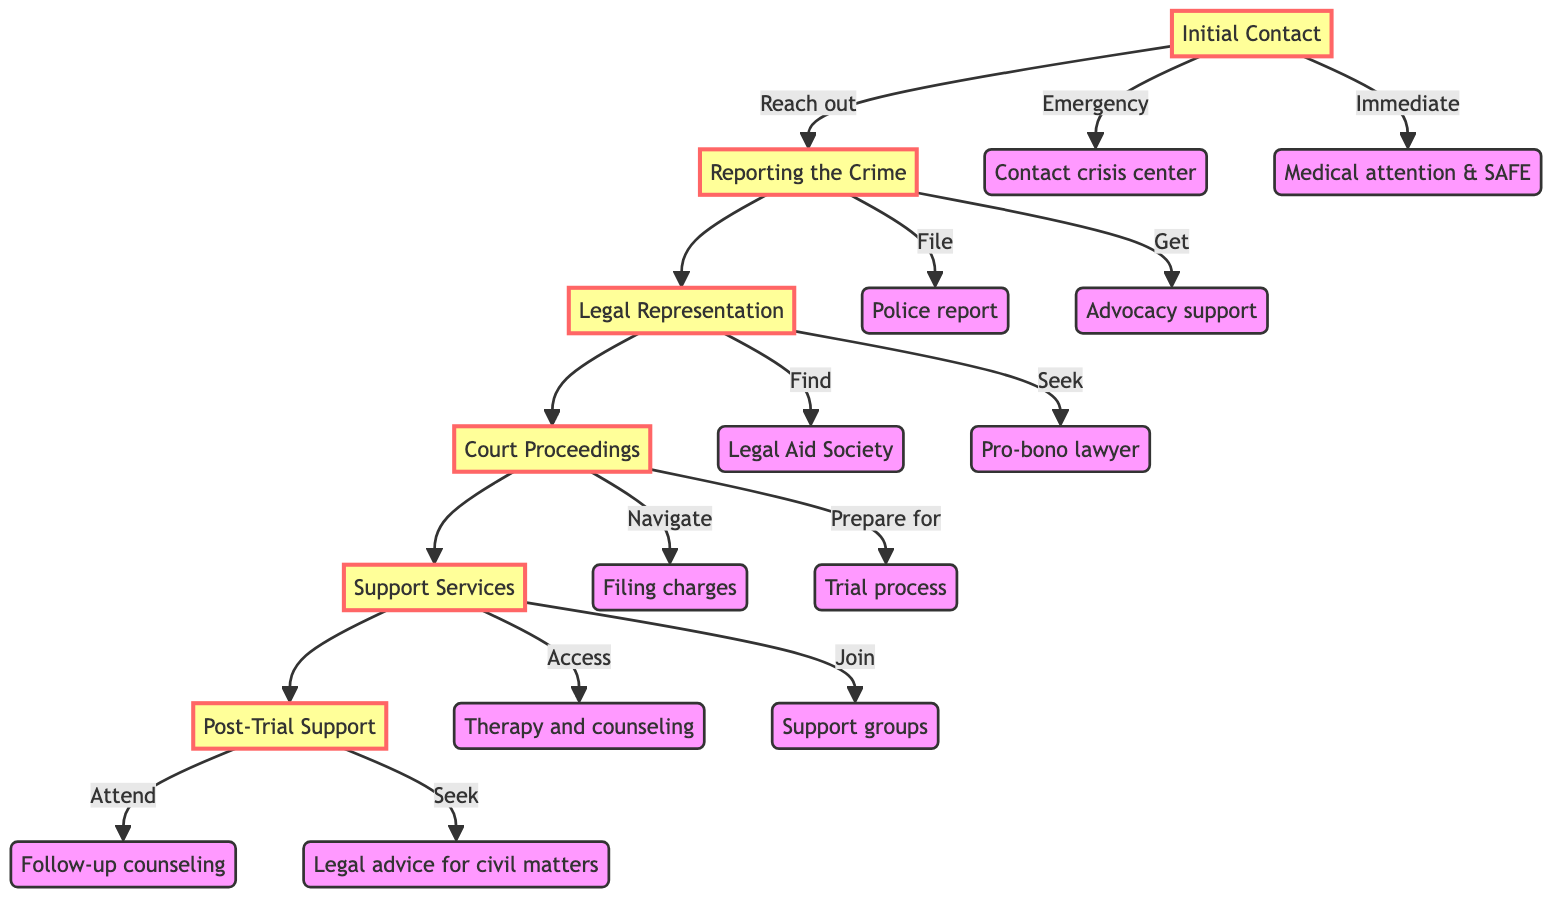What is the first step a survivor should take? The diagram indicates that the first step is "Contact local rape crisis center" under the node "Initial Contact". This is the starting point of seeking help in the process.
Answer: Contact local rape crisis center How many main elements are in the guide? The diagram shows a total of six main elements: Initial Contact, Reporting the Crime, Legal Representation, Court Proceedings, Support Services, and Post-Trial Support. Counting each of these elements gives the total as six.
Answer: 6 What follows after Legal Representation? According to the flowchart, the step that directly follows Legal Representation is Court Proceedings, indicating the progression in the legal process for rape victims.
Answer: Court Proceedings What are the additional resources provided under Support Services? The diagram lists four options under Support Services: "Therapy and counseling options," "Support groups via local NGOs," "Compensation claims through state victim compensation programs," and "Shelter and housing assistance". Together, these represent the resources accessible to survivors.
Answer: Therapy and counseling options, Support groups via local NGOs, Compensation claims, Shelter and housing assistance What is an option available during the Reporting the Crime phase? The diagram highlights that "Advocacy support during reporting" is one of the options available in the Reporting the Crime node, which assists victims through the reporting process.
Answer: Advocacy support during reporting What types of support are available after the trial? The Post-Trial Support element specifies two types of support: "Follow-up counseling sessions" and "Legal advice for related civil matters (e.g., restraining orders)". This shows the continued assistance beyond the courtroom environment.
Answer: Follow-up counseling sessions, Legal advice for civil matters 